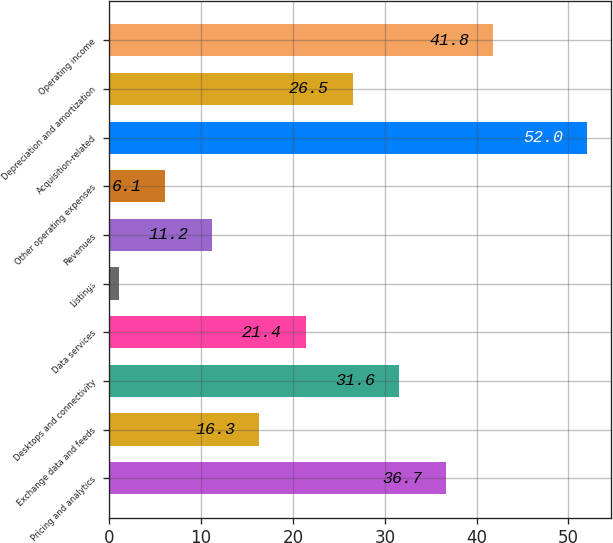Convert chart. <chart><loc_0><loc_0><loc_500><loc_500><bar_chart><fcel>Pricing and analytics<fcel>Exchange data and feeds<fcel>Desktops and connectivity<fcel>Data services<fcel>Listings<fcel>Revenues<fcel>Other operating expenses<fcel>Acquisition-related<fcel>Depreciation and amortization<fcel>Operating income<nl><fcel>36.7<fcel>16.3<fcel>31.6<fcel>21.4<fcel>1<fcel>11.2<fcel>6.1<fcel>52<fcel>26.5<fcel>41.8<nl></chart> 